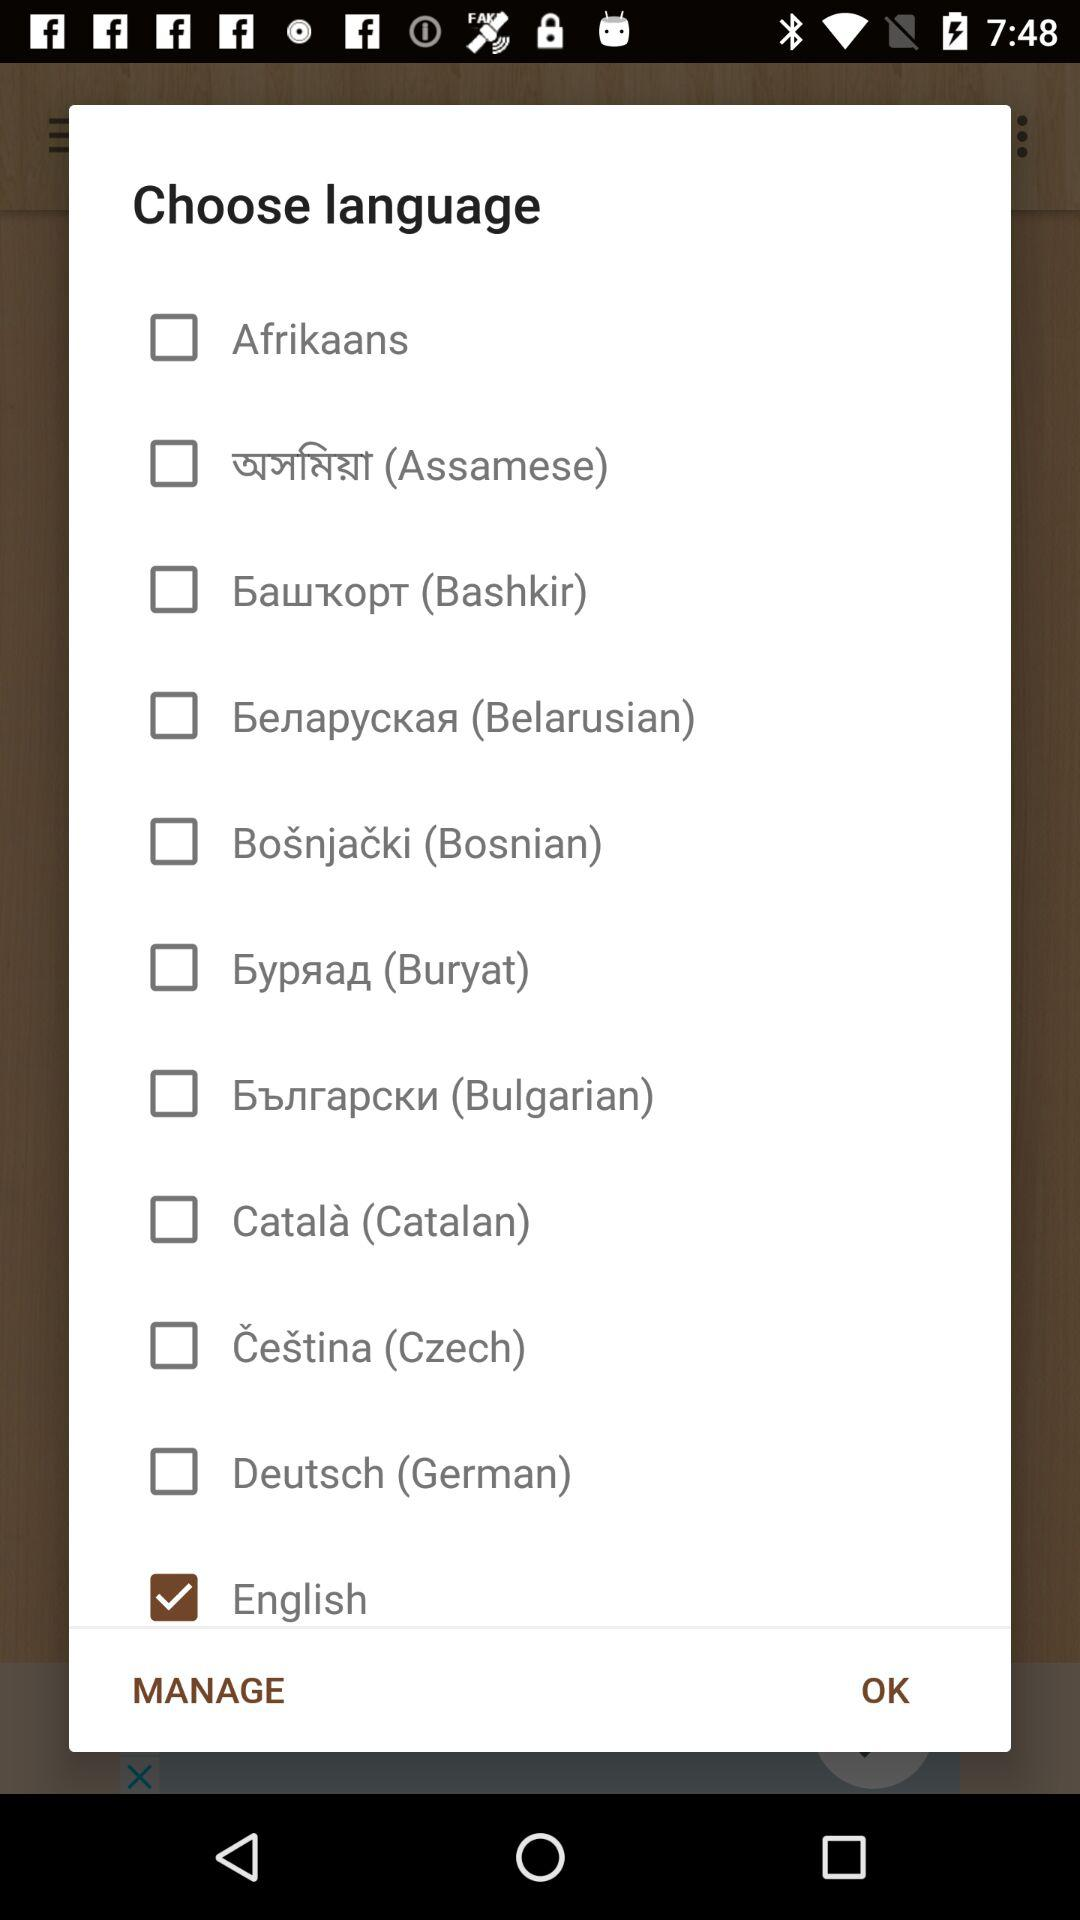What is the selected language? The selected language is English. 